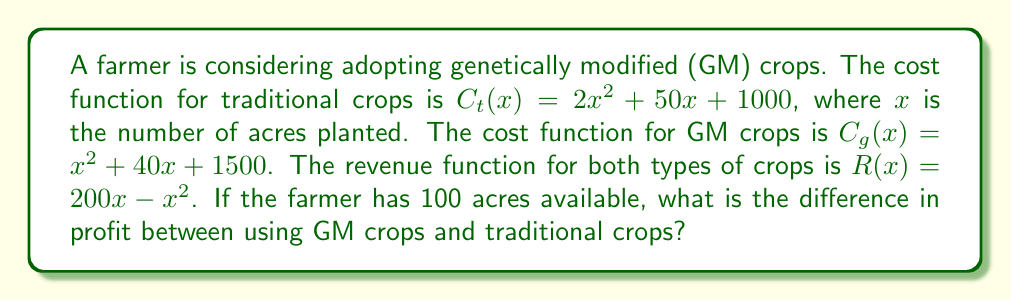Can you solve this math problem? 1) First, let's define the profit function for each type of crop:
   Profit = Revenue - Cost
   
   For traditional crops: $P_t(x) = R(x) - C_t(x) = (200x - x^2) - (2x^2 + 50x + 1000)$
   For GM crops: $P_g(x) = R(x) - C_g(x) = (200x - x^2) - (x^2 + 40x + 1500)$

2) Simplify each profit function:
   $P_t(x) = -3x^2 + 150x - 1000$
   $P_g(x) = -2x^2 + 160x - 1500$

3) The farmer has 100 acres, so we need to evaluate each function at $x = 100$:

   For traditional crops:
   $P_t(100) = -3(100)^2 + 150(100) - 1000$
             $= -30000 + 15000 - 1000$
             $= -16000$

   For GM crops:
   $P_g(100) = -2(100)^2 + 160(100) - 1500$
             $= -20000 + 16000 - 1500$
             $= -5500$

4) Calculate the difference in profit:
   Difference = $P_g(100) - P_t(100) = -5500 - (-16000) = 10500$
Answer: $10500 